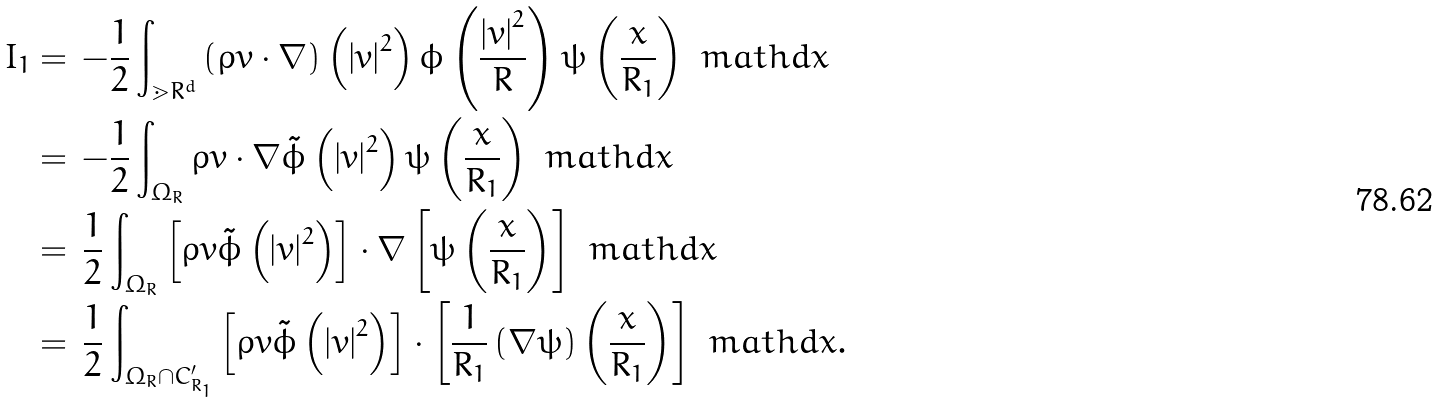<formula> <loc_0><loc_0><loc_500><loc_500>I _ { 1 } & = \, - \frac { 1 } { 2 } \int _ { \mathbb { m } { R } ^ { d } } \left ( \rho v \cdot \nabla \right ) \left ( \left | v \right | ^ { 2 } \right ) \phi \left ( \frac { \left | v \right | ^ { 2 } } { R } \right ) \psi \left ( \frac { x } { R _ { 1 } } \right ) \ m a t h d x \\ & = \, - \frac { 1 } { 2 } \int _ { \Omega _ { R } } \rho v \cdot \nabla \tilde { \phi } \left ( \left | v \right | ^ { 2 } \right ) \psi \left ( \frac { x } { R _ { 1 } } \right ) \ m a t h d x \\ & = \, \frac { 1 } { 2 } \int _ { \Omega _ { R } } \left [ \rho v \tilde { \phi } \left ( \left | v \right | ^ { 2 } \right ) \right ] \cdot \nabla \left [ \psi \left ( \frac { x } { R _ { 1 } } \right ) \right ] \ m a t h d x \\ & = \, \frac { 1 } { 2 } \int _ { \Omega _ { R } \cap C _ { R _ { 1 } } ^ { \prime } } \left [ \rho v \tilde { \phi } \left ( \left | v \right | ^ { 2 } \right ) \right ] \cdot \left [ \frac { 1 } { R _ { 1 } } \left ( \nabla \psi \right ) \left ( \frac { x } { R _ { 1 } } \right ) \right ] \ m a t h d x .</formula> 